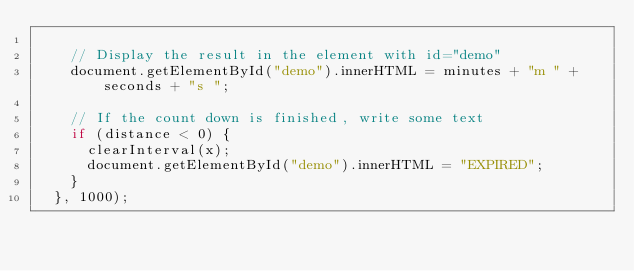<code> <loc_0><loc_0><loc_500><loc_500><_JavaScript_>  
    // Display the result in the element with id="demo"
    document.getElementById("demo").innerHTML = minutes + "m " + seconds + "s ";
  
    // If the count down is finished, write some text
    if (distance < 0) {
      clearInterval(x);
      document.getElementById("demo").innerHTML = "EXPIRED";
    }
  }, 1000);
</code> 